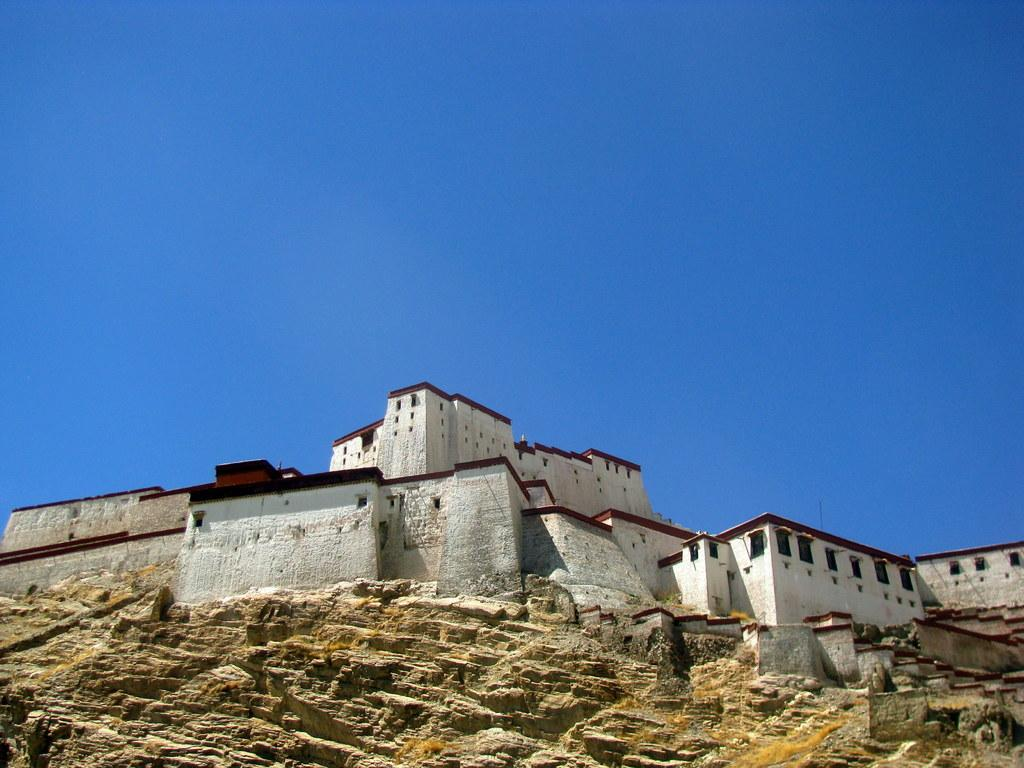What type of structure is present in the image? There is a building in the image. What feature can be observed on the building? The building has a group of windows. Where is the building situated? The building is located on a mountain. What can be seen in the background of the image? The sky is visible in the background of the image. What type of mint can be seen growing on the building in the image? There is no mint plant visible on the building in the image. 